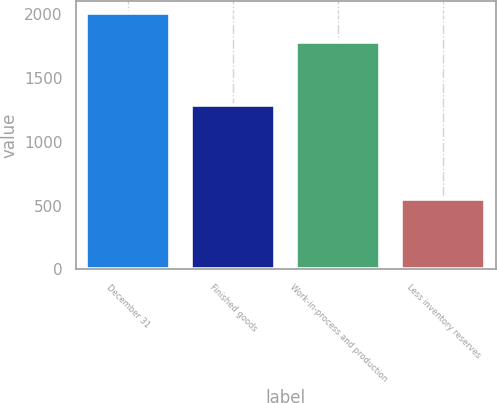<chart> <loc_0><loc_0><loc_500><loc_500><bar_chart><fcel>December 31<fcel>Finished goods<fcel>Work-in-process and production<fcel>Less inventory reserves<nl><fcel>2005<fcel>1287<fcel>1784<fcel>549<nl></chart> 